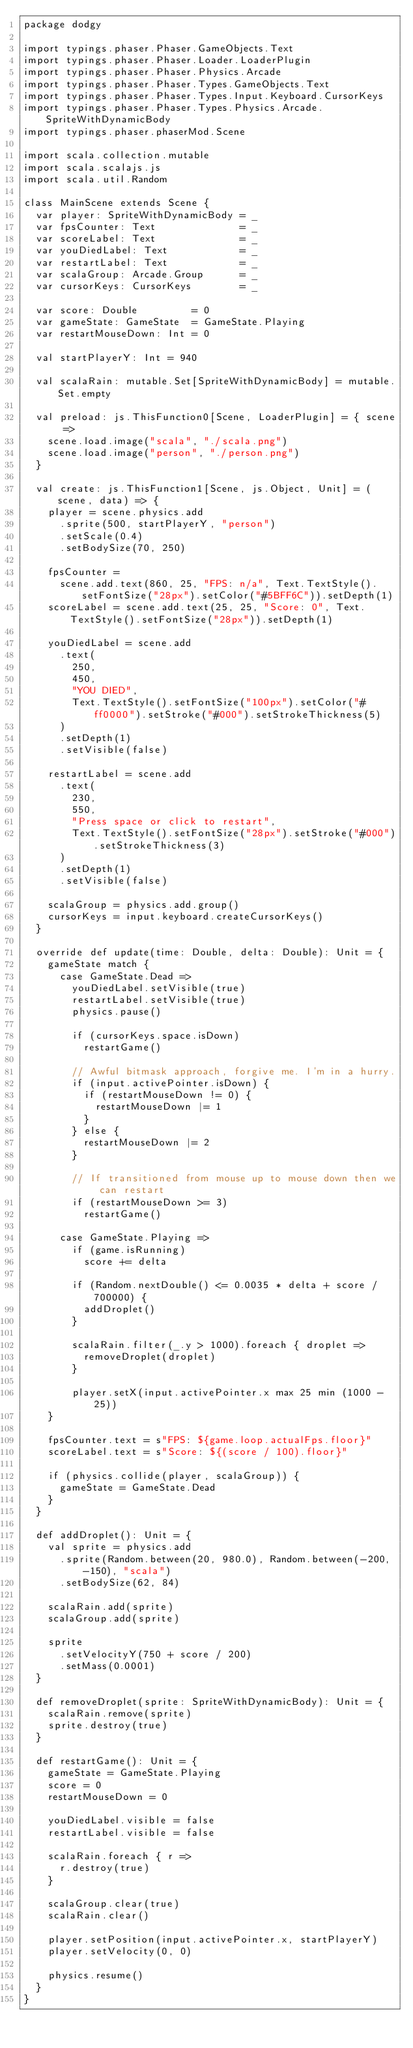Convert code to text. <code><loc_0><loc_0><loc_500><loc_500><_Scala_>package dodgy

import typings.phaser.Phaser.GameObjects.Text
import typings.phaser.Phaser.Loader.LoaderPlugin
import typings.phaser.Phaser.Physics.Arcade
import typings.phaser.Phaser.Types.GameObjects.Text
import typings.phaser.Phaser.Types.Input.Keyboard.CursorKeys
import typings.phaser.Phaser.Types.Physics.Arcade.SpriteWithDynamicBody
import typings.phaser.phaserMod.Scene

import scala.collection.mutable
import scala.scalajs.js
import scala.util.Random

class MainScene extends Scene {
  var player: SpriteWithDynamicBody = _
  var fpsCounter: Text              = _
  var scoreLabel: Text              = _
  var youDiedLabel: Text            = _
  var restartLabel: Text            = _
  var scalaGroup: Arcade.Group      = _
  var cursorKeys: CursorKeys        = _

  var score: Double         = 0
  var gameState: GameState  = GameState.Playing
  var restartMouseDown: Int = 0

  val startPlayerY: Int = 940

  val scalaRain: mutable.Set[SpriteWithDynamicBody] = mutable.Set.empty

  val preload: js.ThisFunction0[Scene, LoaderPlugin] = { scene =>
    scene.load.image("scala", "./scala.png")
    scene.load.image("person", "./person.png")
  }

  val create: js.ThisFunction1[Scene, js.Object, Unit] = (scene, data) => {
    player = scene.physics.add
      .sprite(500, startPlayerY, "person")
      .setScale(0.4)
      .setBodySize(70, 250)

    fpsCounter =
      scene.add.text(860, 25, "FPS: n/a", Text.TextStyle().setFontSize("28px").setColor("#5BFF6C")).setDepth(1)
    scoreLabel = scene.add.text(25, 25, "Score: 0", Text.TextStyle().setFontSize("28px")).setDepth(1)

    youDiedLabel = scene.add
      .text(
        250,
        450,
        "YOU DIED",
        Text.TextStyle().setFontSize("100px").setColor("#ff0000").setStroke("#000").setStrokeThickness(5)
      )
      .setDepth(1)
      .setVisible(false)

    restartLabel = scene.add
      .text(
        230,
        550,
        "Press space or click to restart",
        Text.TextStyle().setFontSize("28px").setStroke("#000").setStrokeThickness(3)
      )
      .setDepth(1)
      .setVisible(false)

    scalaGroup = physics.add.group()
    cursorKeys = input.keyboard.createCursorKeys()
  }

  override def update(time: Double, delta: Double): Unit = {
    gameState match {
      case GameState.Dead =>
        youDiedLabel.setVisible(true)
        restartLabel.setVisible(true)
        physics.pause()

        if (cursorKeys.space.isDown)
          restartGame()

        // Awful bitmask approach, forgive me. I'm in a hurry.
        if (input.activePointer.isDown) {
          if (restartMouseDown != 0) {
            restartMouseDown |= 1
          }
        } else {
          restartMouseDown |= 2
        }

        // If transitioned from mouse up to mouse down then we can restart
        if (restartMouseDown >= 3)
          restartGame()

      case GameState.Playing =>
        if (game.isRunning)
          score += delta

        if (Random.nextDouble() <= 0.0035 * delta + score / 700000) {
          addDroplet()
        }

        scalaRain.filter(_.y > 1000).foreach { droplet =>
          removeDroplet(droplet)
        }

        player.setX(input.activePointer.x max 25 min (1000 - 25))
    }

    fpsCounter.text = s"FPS: ${game.loop.actualFps.floor}"
    scoreLabel.text = s"Score: ${(score / 100).floor}"

    if (physics.collide(player, scalaGroup)) {
      gameState = GameState.Dead
    }
  }

  def addDroplet(): Unit = {
    val sprite = physics.add
      .sprite(Random.between(20, 980.0), Random.between(-200, -150), "scala")
      .setBodySize(62, 84)

    scalaRain.add(sprite)
    scalaGroup.add(sprite)

    sprite
      .setVelocityY(750 + score / 200)
      .setMass(0.0001)
  }

  def removeDroplet(sprite: SpriteWithDynamicBody): Unit = {
    scalaRain.remove(sprite)
    sprite.destroy(true)
  }

  def restartGame(): Unit = {
    gameState = GameState.Playing
    score = 0
    restartMouseDown = 0

    youDiedLabel.visible = false
    restartLabel.visible = false

    scalaRain.foreach { r =>
      r.destroy(true)
    }

    scalaGroup.clear(true)
    scalaRain.clear()

    player.setPosition(input.activePointer.x, startPlayerY)
    player.setVelocity(0, 0)

    physics.resume()
  }
}
</code> 